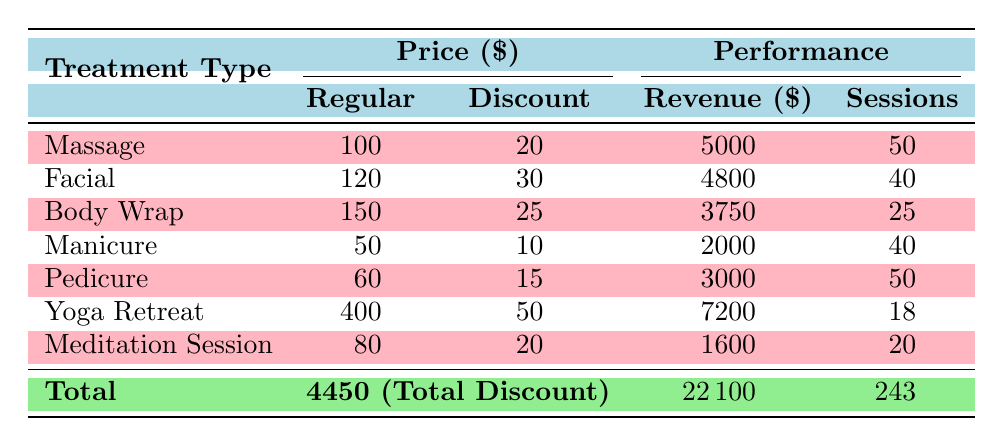What is the total revenue generated from all treatment types? The table provides a total revenue row, which states the total revenue is $22,100.
Answer: 22100 How much discount is given to surgeons for the Facial treatment? The Facial treatment row indicates that the surgeon discount is $30.
Answer: 30 Which treatment has the highest revenue? By observing the revenue values, the Yoga Retreat has the highest revenue at $7,200.
Answer: Yoga Retreat How many sessions were held for the Massage treatment? The table shows that the number of sessions for Massage is 50.
Answer: 50 What is the total number of sessions across all treatment types? The total sessions are displayed in the total row as 243.
Answer: 243 What is the difference in revenue between the Manicure and Pedicure treatments? The revenue for Manicure is $2,000 and for Pedicure is $3,000. The difference is $3,000 - $2,000 = $1,000.
Answer: 1000 Which treatment type offers the highest discount? By comparing the discounts, Yoga Retreat offers the highest discount of $50.
Answer: Yoga Retreat What is the average discount given per treatment type? There are 7 treatment types with a total discount of $4,450. The average discount is $4,450 / 7 ≈ $635.71.
Answer: Approximately 635.71 What percentage of the total revenue is generated from the Meditation Session? The revenue from Meditation Session is $1,600. The percentage is ($1,600 / $22,100) * 100 ≈ 7.24%.
Answer: Approximately 7.24% If a surgeon gets a discount for 2 sessions of each treatment type, how much total discount would they receive? The surgeon discount totals for each treatment type are added: (20 + 30 + 25 + 10 + 15 + 50 + 20) * 2 = 170.
Answer: 170 